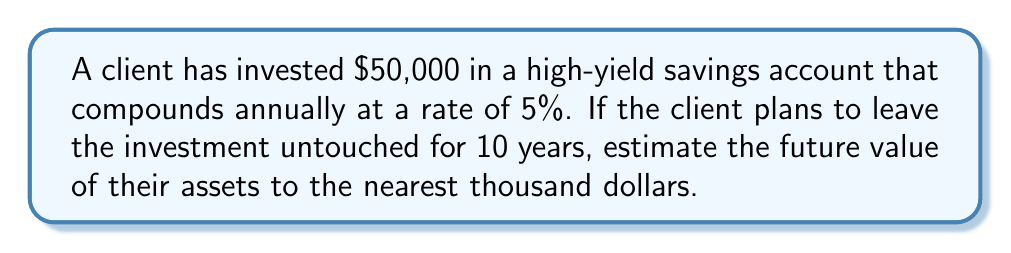Could you help me with this problem? To solve this problem, we'll use the compound interest formula:

$$ A = P(1 + r)^t $$

Where:
$A$ = Final amount
$P$ = Principal (initial investment)
$r$ = Annual interest rate (as a decimal)
$t$ = Time in years

Given:
$P = $50,000$
$r = 5\% = 0.05$
$t = 10$ years

Let's substitute these values into the formula:

$$ A = 50,000(1 + 0.05)^{10} $$

Now, let's calculate step-by-step:

1) First, calculate $(1 + 0.05)^{10}$:
   $$(1.05)^{10} \approx 1.6288946$$

2) Multiply this by the principal:
   $$50,000 \times 1.6288946 \approx 81,444.73$$

3) Round to the nearest thousand:
   $$81,444.73 \approx 81,000$$

Therefore, the estimated future value of the client's assets after 10 years is $81,000.
Answer: $81,000 